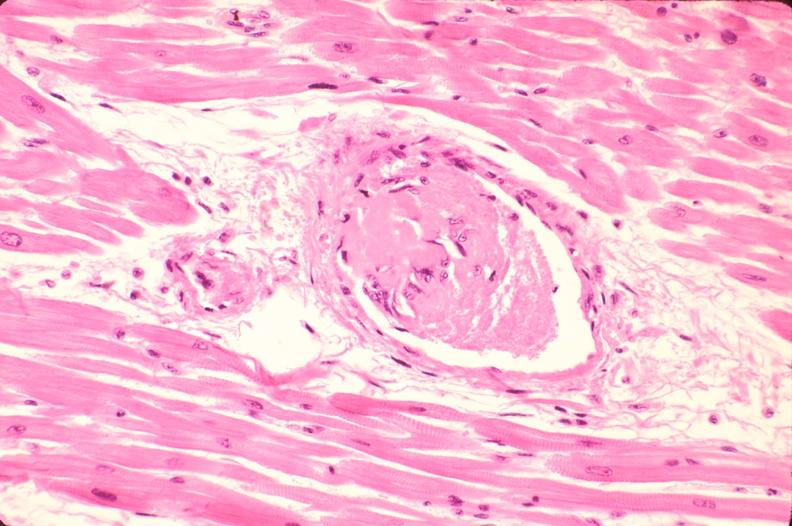what is present?
Answer the question using a single word or phrase. Cardiovascular 